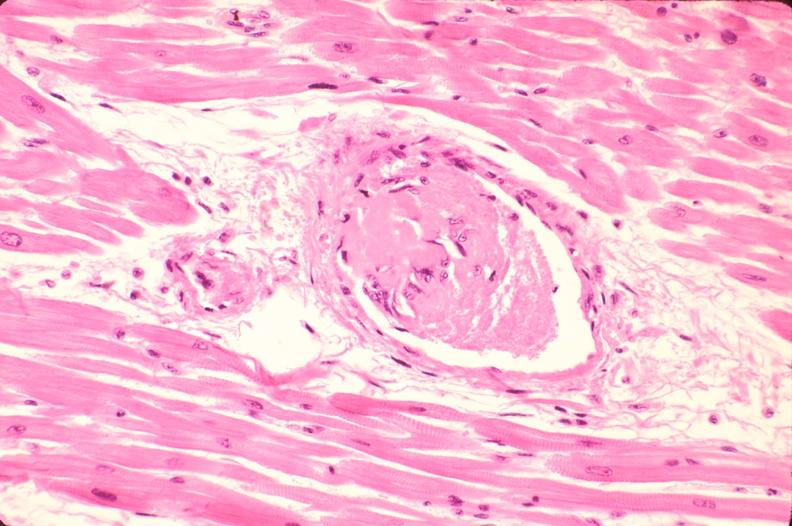what is present?
Answer the question using a single word or phrase. Cardiovascular 